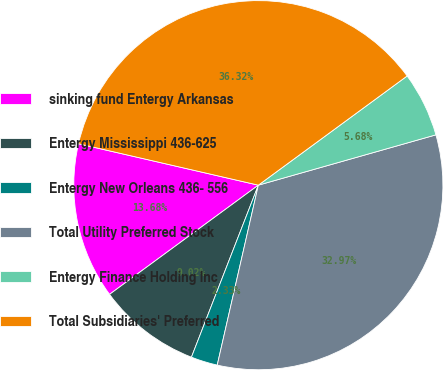Convert chart. <chart><loc_0><loc_0><loc_500><loc_500><pie_chart><fcel>sinking fund Entergy Arkansas<fcel>Entergy Mississippi 436-625<fcel>Entergy New Orleans 436- 556<fcel>Total Utility Preferred Stock<fcel>Entergy Finance Holding Inc<fcel>Total Subsidiaries' Preferred<nl><fcel>13.68%<fcel>9.02%<fcel>2.33%<fcel>32.97%<fcel>5.68%<fcel>36.32%<nl></chart> 